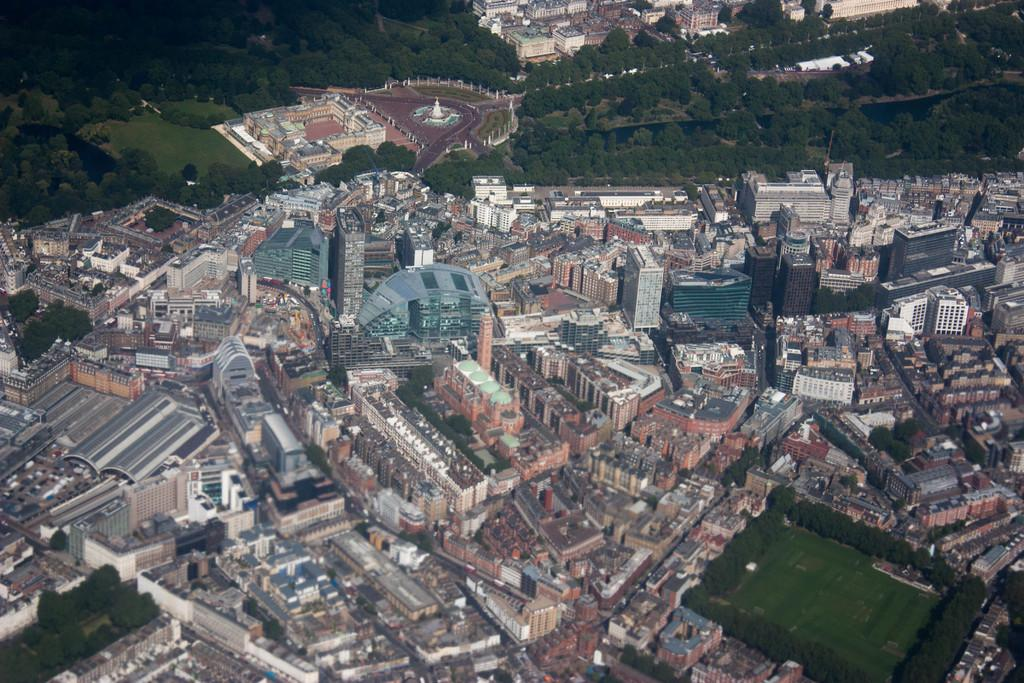What type of view is shown in the image? The image is an aerial view. What structures can be seen in the image? There are buildings and skyscrapers in the image. What type of transportation infrastructure is visible in the image? There are roads in the image. What type of natural elements can be seen in the image? There are trees and grounds in the image. What type of man-made objects can be seen in motion in the image? There are motor vehicles in the image. Can you hear the army marching in the image? There is no sound in the image, and there is no indication of an army or marching. Is there a stage visible in the image? There is no stage present in the image. 